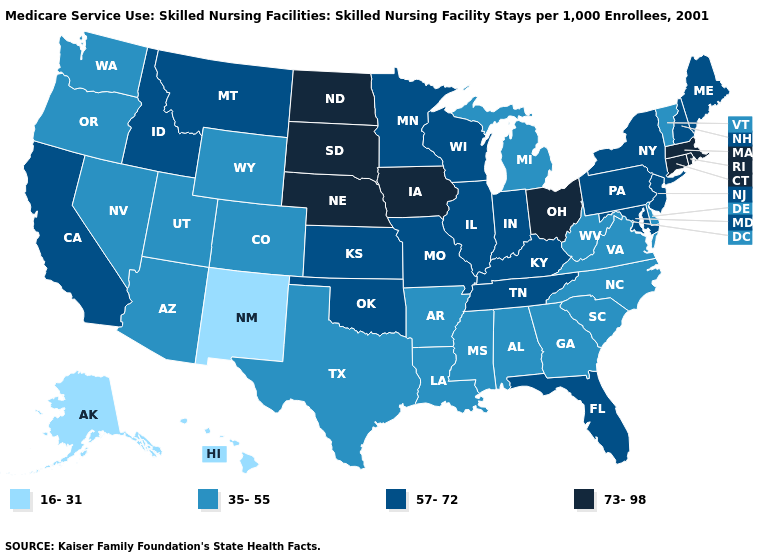Name the states that have a value in the range 57-72?
Be succinct. California, Florida, Idaho, Illinois, Indiana, Kansas, Kentucky, Maine, Maryland, Minnesota, Missouri, Montana, New Hampshire, New Jersey, New York, Oklahoma, Pennsylvania, Tennessee, Wisconsin. Which states have the lowest value in the USA?
Quick response, please. Alaska, Hawaii, New Mexico. Which states have the highest value in the USA?
Quick response, please. Connecticut, Iowa, Massachusetts, Nebraska, North Dakota, Ohio, Rhode Island, South Dakota. Which states hav the highest value in the West?
Answer briefly. California, Idaho, Montana. Which states have the highest value in the USA?
Be succinct. Connecticut, Iowa, Massachusetts, Nebraska, North Dakota, Ohio, Rhode Island, South Dakota. Does the first symbol in the legend represent the smallest category?
Short answer required. Yes. Does Pennsylvania have a lower value than North Dakota?
Answer briefly. Yes. What is the lowest value in states that border Louisiana?
Concise answer only. 35-55. Name the states that have a value in the range 57-72?
Quick response, please. California, Florida, Idaho, Illinois, Indiana, Kansas, Kentucky, Maine, Maryland, Minnesota, Missouri, Montana, New Hampshire, New Jersey, New York, Oklahoma, Pennsylvania, Tennessee, Wisconsin. What is the value of Georgia?
Quick response, please. 35-55. Does Virginia have the highest value in the South?
Keep it brief. No. What is the value of Montana?
Be succinct. 57-72. Name the states that have a value in the range 35-55?
Concise answer only. Alabama, Arizona, Arkansas, Colorado, Delaware, Georgia, Louisiana, Michigan, Mississippi, Nevada, North Carolina, Oregon, South Carolina, Texas, Utah, Vermont, Virginia, Washington, West Virginia, Wyoming. What is the highest value in states that border Washington?
Write a very short answer. 57-72. What is the value of New Jersey?
Short answer required. 57-72. 